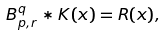<formula> <loc_0><loc_0><loc_500><loc_500>\ B _ { p , r } ^ { q } \ast K ( x ) = R ( x ) ,</formula> 